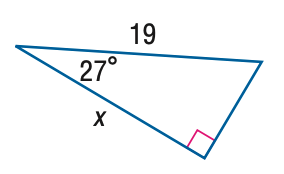Question: Find x. Round to the nearest hundredth.
Choices:
A. 8.63
B. 9.68
C. 16.93
D. 41.85
Answer with the letter. Answer: C 